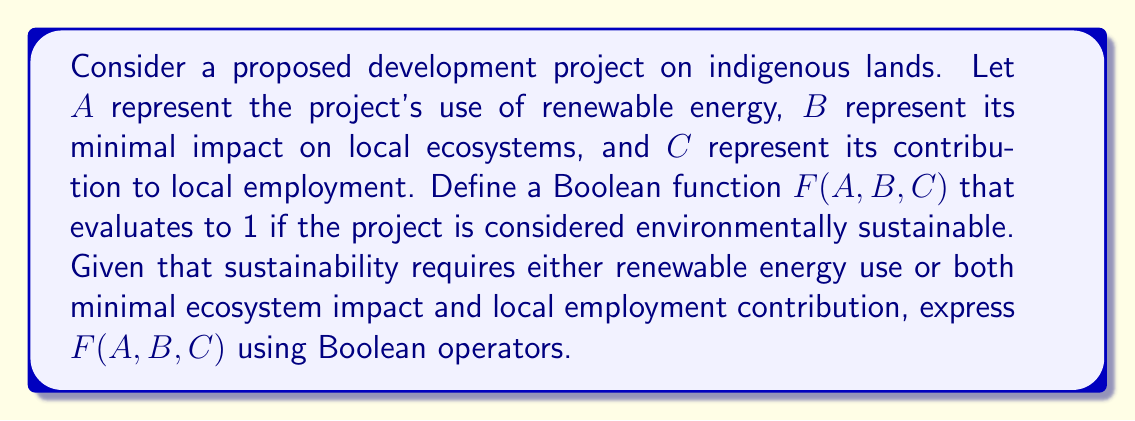Help me with this question. To solve this problem, we need to translate the sustainability criteria into a Boolean function:

1. The project is sustainable if it uses renewable energy (A), OR
2. The project is sustainable if it has minimal impact on ecosystems (B) AND contributes to local employment (C)

We can express this logic using Boolean operators:

$$F(A,B,C) = A + (B \cdot C)$$

Where:
- $+$ represents the OR operation
- $\cdot$ represents the AND operation

This function will evaluate to 1 (true) in the following cases:
- $A = 1$ (regardless of B and C)
- $B = 1$ AND $C = 1$ (when $A = 0$)

The function will evaluate to 0 (false) in all other cases, indicating that the project is not considered environmentally sustainable.

This Boolean function allows the government official to quickly assess the environmental sustainability of proposed developments based on key criteria, balancing the protection of indigenous lands with modern development goals.
Answer: $F(A,B,C) = A + (B \cdot C)$ 